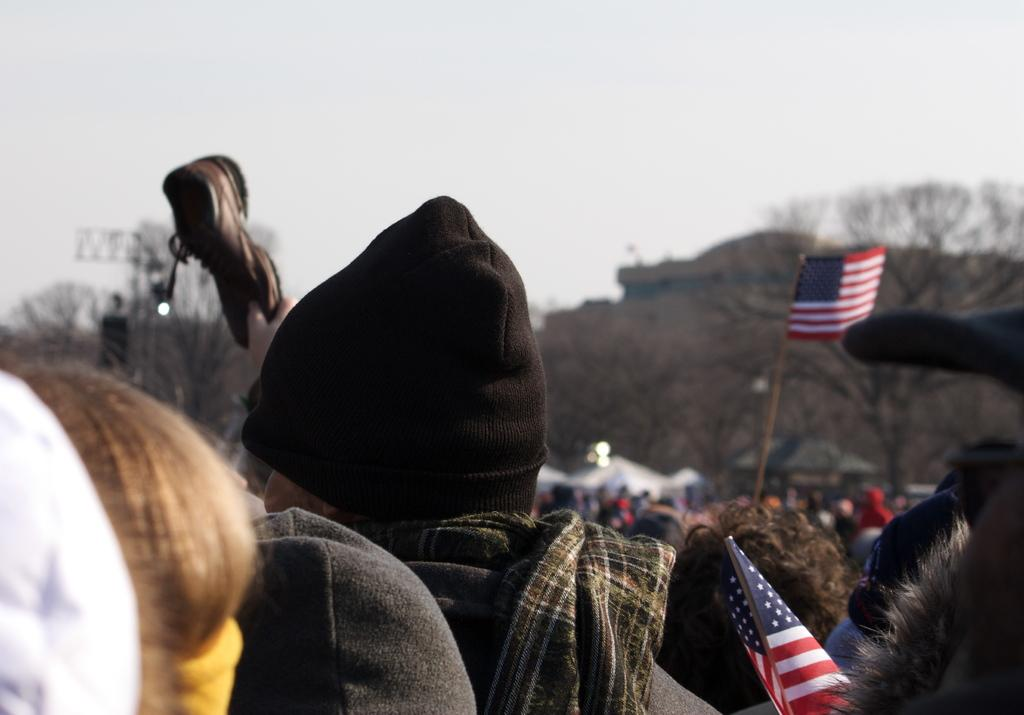How many people are visible in the image? There are a few people in the image. What is located in front of the people? There is a flag and stalls in front of the people. What can be seen in the background of the image? There are dried trees and mountains in the background of the image. What type of error can be seen in the image? There is no error present in the image. Can you identify any spies in the image? There is no indication of spies in the image. 